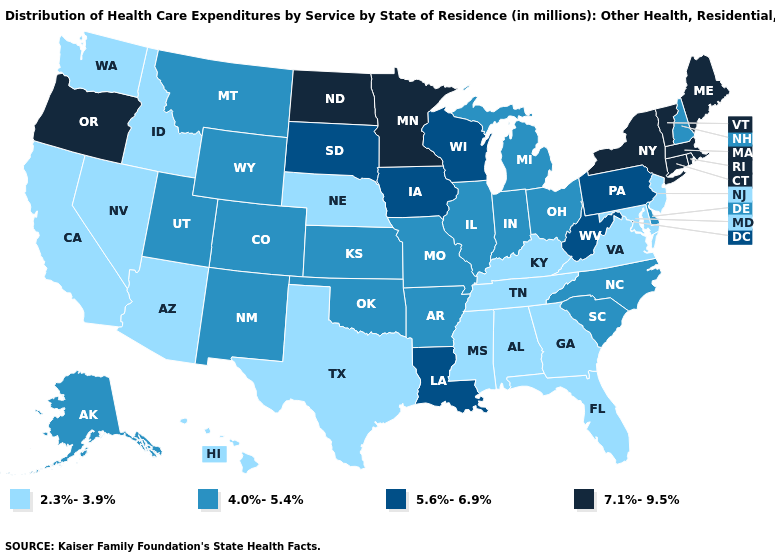What is the value of Illinois?
Give a very brief answer. 4.0%-5.4%. What is the value of Rhode Island?
Be succinct. 7.1%-9.5%. What is the highest value in the USA?
Keep it brief. 7.1%-9.5%. What is the value of Montana?
Give a very brief answer. 4.0%-5.4%. Name the states that have a value in the range 5.6%-6.9%?
Concise answer only. Iowa, Louisiana, Pennsylvania, South Dakota, West Virginia, Wisconsin. What is the value of Rhode Island?
Give a very brief answer. 7.1%-9.5%. Does Arkansas have the highest value in the USA?
Keep it brief. No. What is the value of Indiana?
Give a very brief answer. 4.0%-5.4%. What is the value of Hawaii?
Keep it brief. 2.3%-3.9%. What is the value of Alabama?
Be succinct. 2.3%-3.9%. Does Hawaii have the same value as Washington?
Concise answer only. Yes. Does West Virginia have a higher value than New York?
Concise answer only. No. Does West Virginia have the highest value in the South?
Give a very brief answer. Yes. Which states have the lowest value in the Northeast?
Concise answer only. New Jersey. Name the states that have a value in the range 7.1%-9.5%?
Write a very short answer. Connecticut, Maine, Massachusetts, Minnesota, New York, North Dakota, Oregon, Rhode Island, Vermont. 